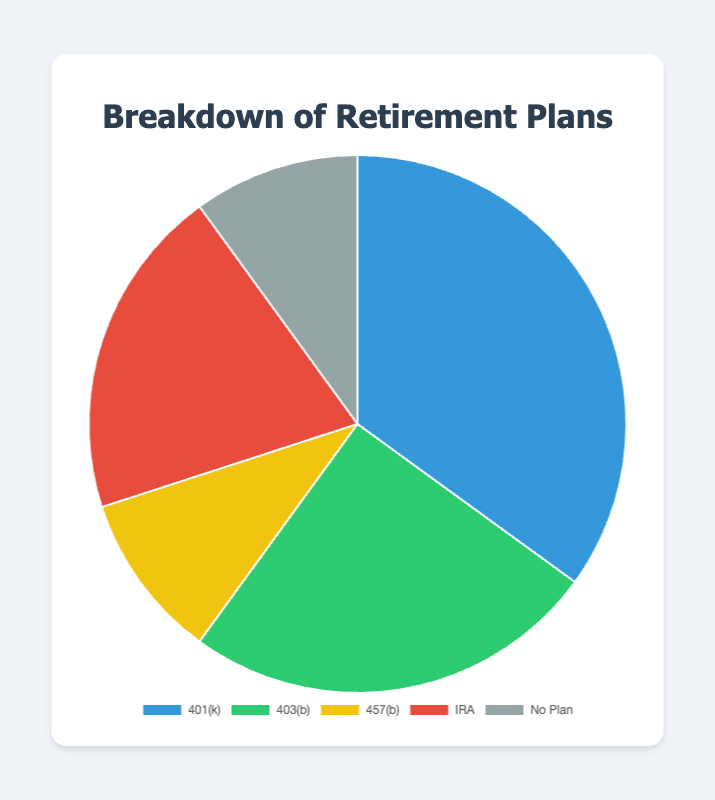What percentage of employees are enrolled in the 401(k) plan? The 401(k) plan has 35 employees enrolled. To find the percentage, divide 35 by the total number of employees (35 + 25 + 10 + 20 + 10 = 100), then multiply by 100. (35/100) * 100 = 35%
Answer: 35% Which retirement plan has the least number of employees enrolled? By comparing the number of employees enrolled in each plan, the 457(b) and No Plan both have the least number of employees enrolled, which is 10.
Answer: 457(b), No Plan How many more employees are enrolled in the 401(k) plan compared to the 403(b) plan? To find the difference in enrollment between the 401(k) and 403(b) plans, subtract the number of 403(b) enrollees from the 401(k) enrollees. 35 - 25 = 10
Answer: 10 Which plan has the second-highest number of employees enrolled? By ordering the plans based on the number of enrollees, we see 401(k) has the highest (35), and 403(b) has the second-highest with 25 employees enrolled.
Answer: 403(b) What is the percentage of employees not enrolled in any retirement plan? The number of employees with No Plan is 10. To find the percentage, divide 10 by the total number of employees (100) and multiply by 100. (10/100) * 100 = 10%
Answer: 10% If you combined the employees enrolled in the 457(b) and IRA plans, how many employees are covered? Add the number of employees in the 457(b) plan (10) to those in the IRA plan (20). 10 + 20 = 30
Answer: 30 Which plan's slice appears red in the pie chart? According to the pie chart, the slice representing the IRA plan is colored red.
Answer: IRA What is the total number of employees enrolled in some form of retirement plan? Add up the number of employees in 401(k), 403(b), 457(b), and IRA plans: 35 + 25 + 10 + 20 = 90
Answer: 90 What proportion of employees are enrolled in either the 401(k) or 403(b) plans? To find the proportion, add the employees in 401(k) and 403(b) plans and then divide by the total number of employees: (35 + 25) / 100 = 60/100 = 0.6, or 60%
Answer: 60% Are there more employees enrolled in the IRA plan or in the No Plan category? By how much? The enrollment in the IRA plan is 20 and in the No Plan category is 10. Subtract the No Plan from the IRA plan: 20 - 10 = 10.
Answer: Yes, 10 more 